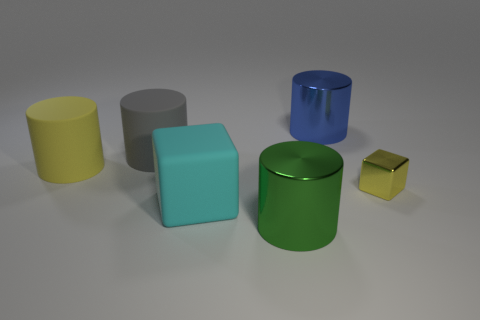Add 2 rubber blocks. How many objects exist? 8 Subtract all blocks. How many objects are left? 4 Subtract all blue metallic things. Subtract all large yellow cylinders. How many objects are left? 4 Add 1 large green cylinders. How many large green cylinders are left? 2 Add 5 large metal cylinders. How many large metal cylinders exist? 7 Subtract 1 yellow cylinders. How many objects are left? 5 